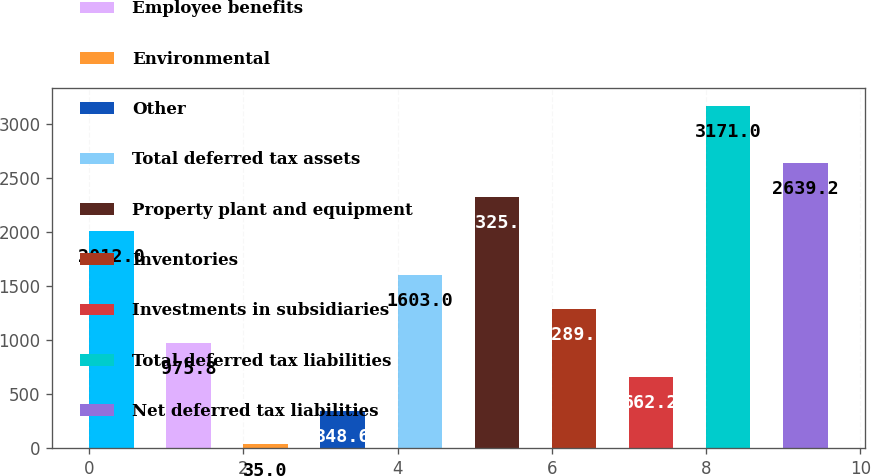<chart> <loc_0><loc_0><loc_500><loc_500><bar_chart><fcel>(In millions)<fcel>Employee benefits<fcel>Environmental<fcel>Other<fcel>Total deferred tax assets<fcel>Property plant and equipment<fcel>Inventories<fcel>Investments in subsidiaries<fcel>Total deferred tax liabilities<fcel>Net deferred tax liabilities<nl><fcel>2012<fcel>975.8<fcel>35<fcel>348.6<fcel>1603<fcel>2325.6<fcel>1289.4<fcel>662.2<fcel>3171<fcel>2639.2<nl></chart> 